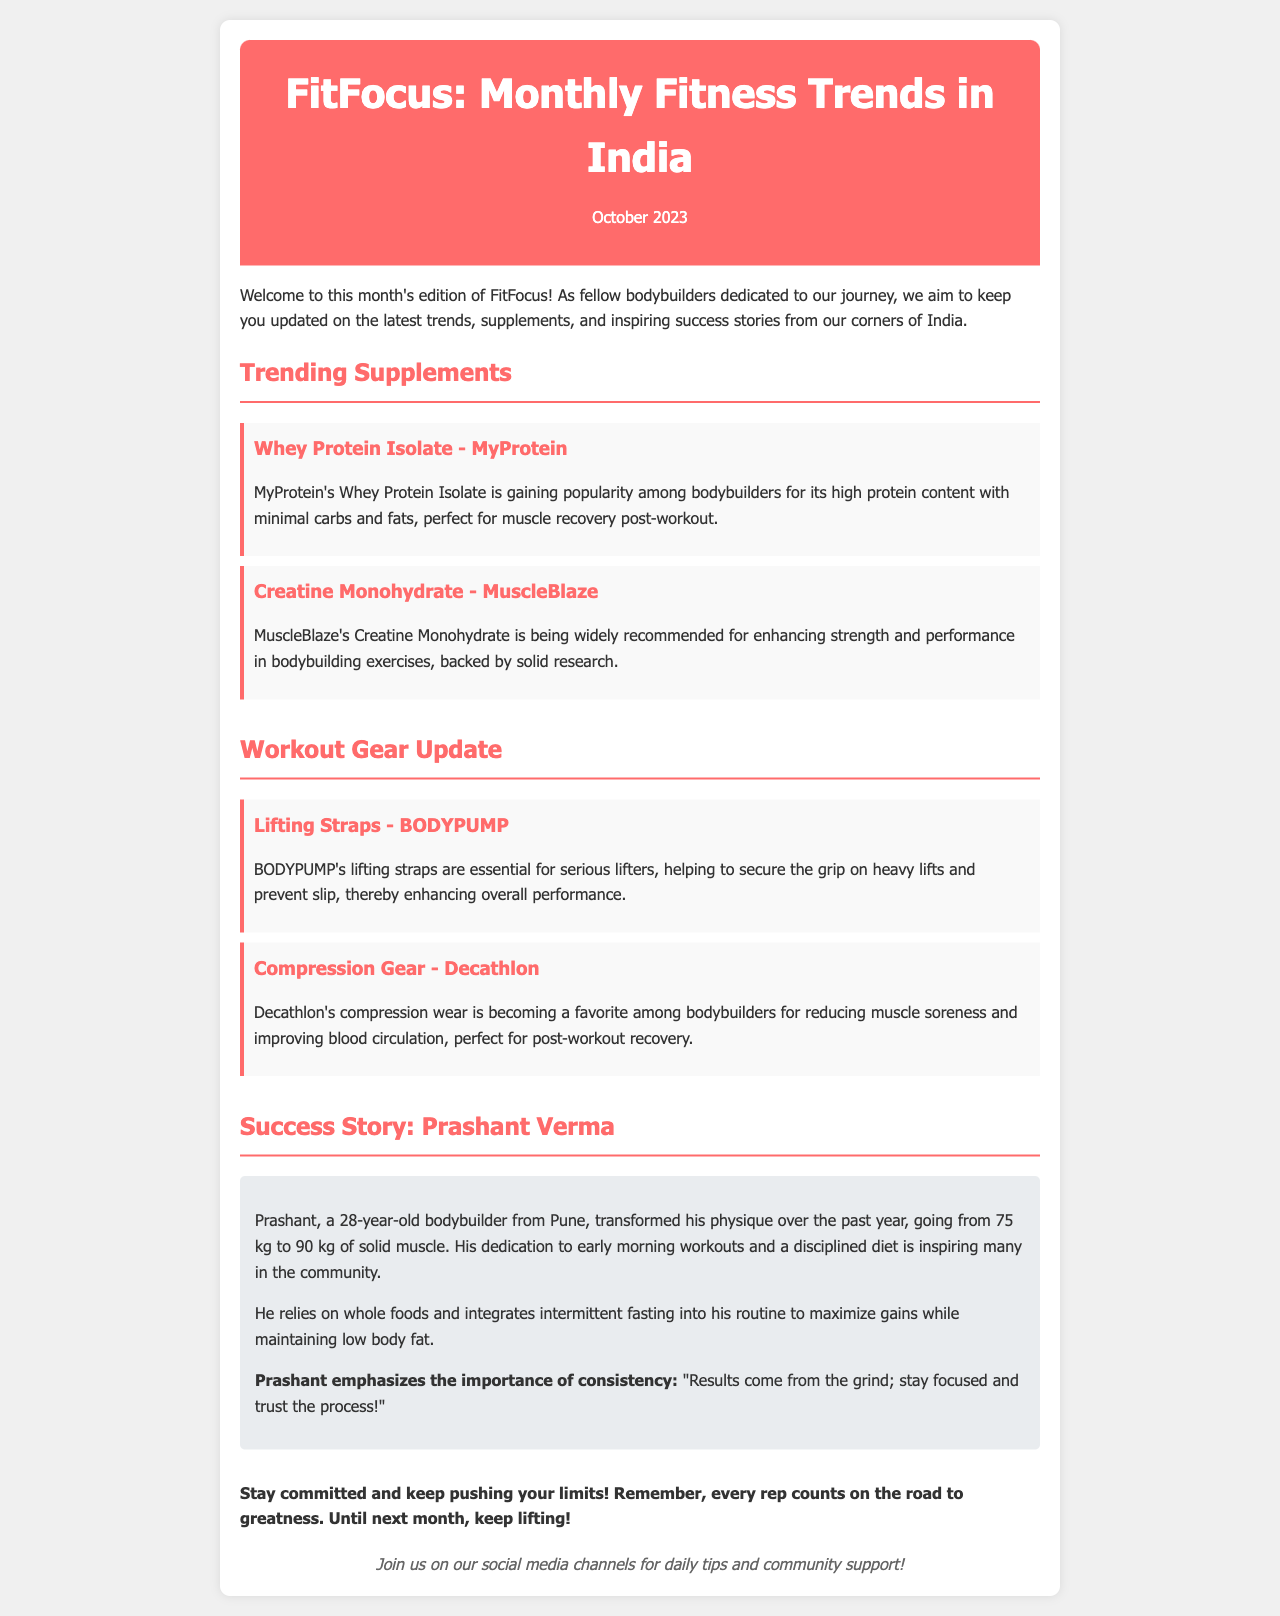what is the title of the newsletter? The title of the newsletter is stated clearly at the top of the document.
Answer: FitFocus: Monthly Fitness Trends in India what is the popular protein supplement mentioned? The document names a specific protein supplement that is gaining popularity among bodybuilders.
Answer: Whey Protein Isolate - MyProtein who is the success story featured in this edition? The document highlights an individual's journey in the fitness community as a success story.
Answer: Prashant Verma which lifting gear is recommended for serious lifters? A specific workout gear is mentioned that helps with grip during heavy lifts.
Answer: Lifting Straps - BODYPUMP how much weight did Prashant transform from and to? The success story includes specific weight measurements before and after Prashant's transformation.
Answer: 75 kg to 90 kg what type of gear is Decathlon popular for? The document notes the specific type of gear that is becoming a favorite among bodybuilders for recovery.
Answer: Compression Gear what month is this newsletter for? The newsletter specifies the month it relates to in the header section.
Answer: October 2023 what does Prashant emphasize in his success story? The emphasis in Prashant's quote reflects his mindset towards training and results.
Answer: consistency how many supplements are highlighted in the newsletter? The document highlights a total of two supplements in the section.
Answer: 2 